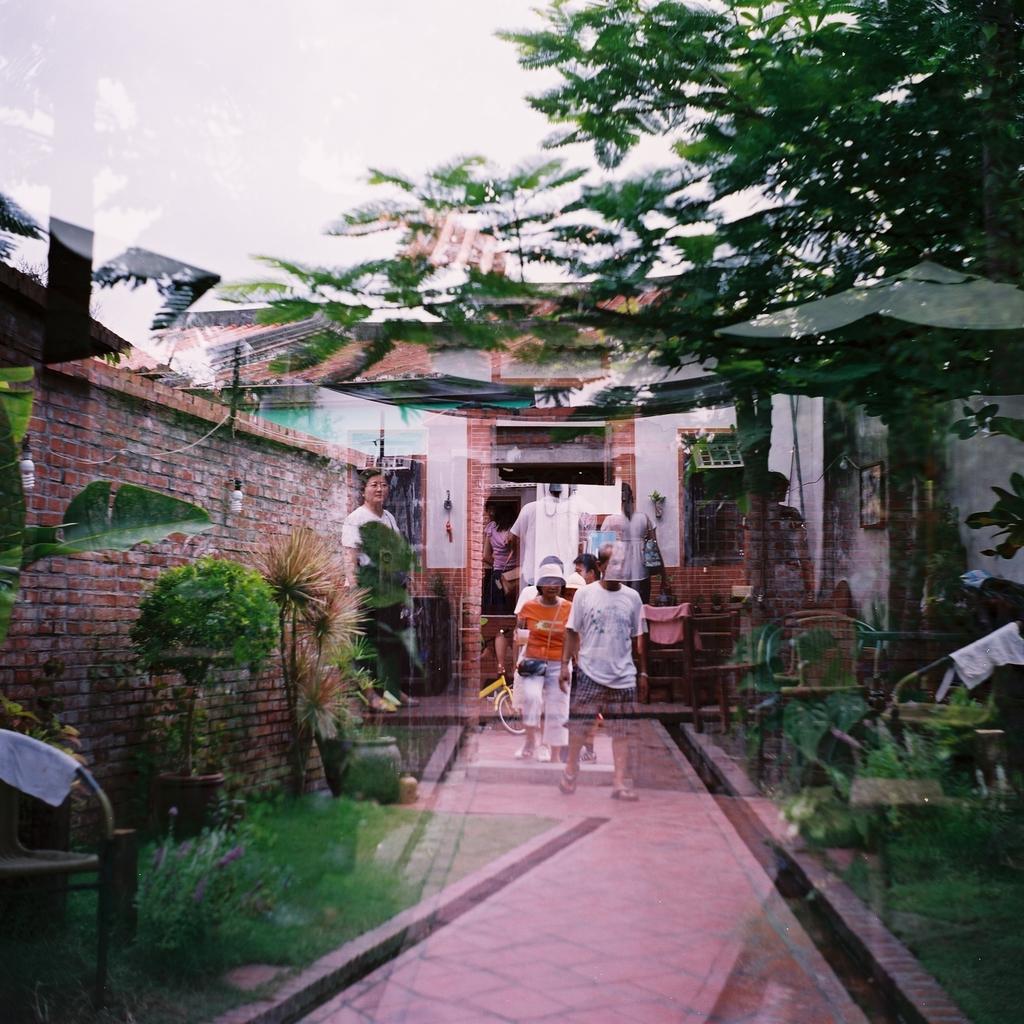How would you summarize this image in a sentence or two? This is an edited picture. In the middle of the image there are group of people and there is a building and there are trees and plants. On the right side of the image there is a table and there are chairs and there is a frame on the wall. On the left side of the image there is a wall. At the top there is sky. At the bottom there is a pavement and there is grass. 